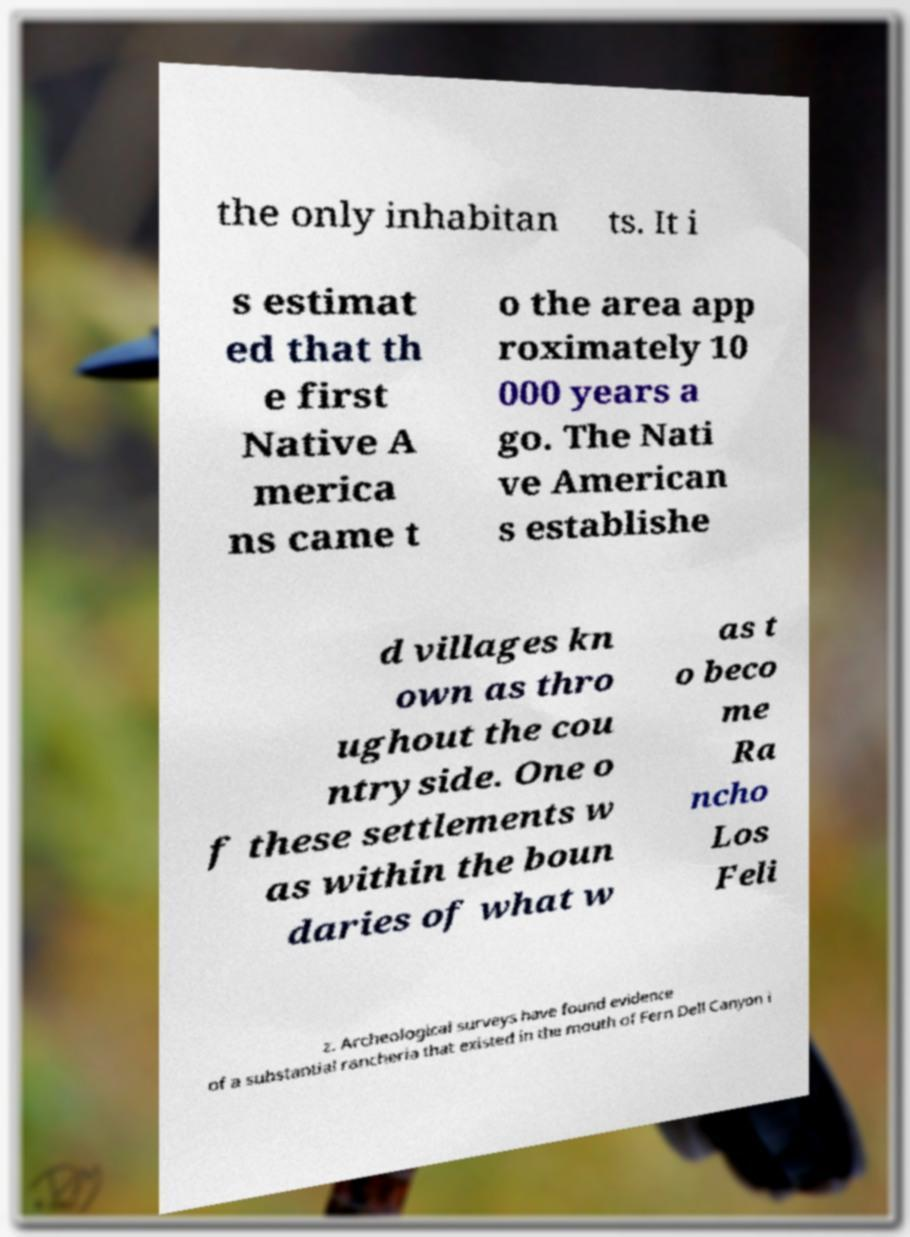There's text embedded in this image that I need extracted. Can you transcribe it verbatim? the only inhabitan ts. It i s estimat ed that th e first Native A merica ns came t o the area app roximately 10 000 years a go. The Nati ve American s establishe d villages kn own as thro ughout the cou ntryside. One o f these settlements w as within the boun daries of what w as t o beco me Ra ncho Los Feli z. Archeological surveys have found evidence of a substantial rancheria that existed in the mouth of Fern Dell Canyon i 